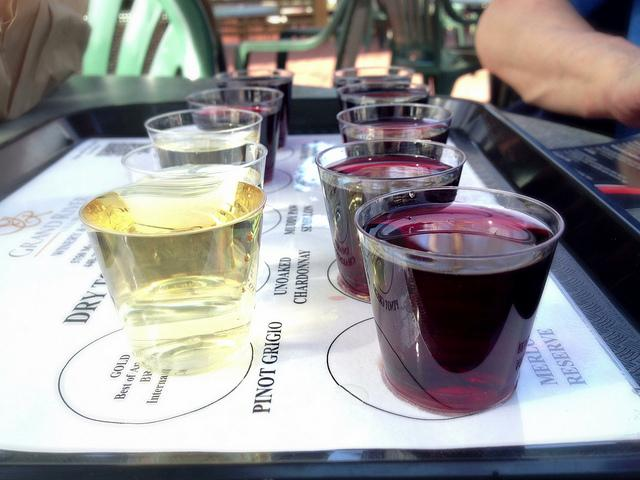What does the printing on the mat indicate? Please explain your reasoning. wine varieties. There are different glasses of wine on the respective places of the mat. 